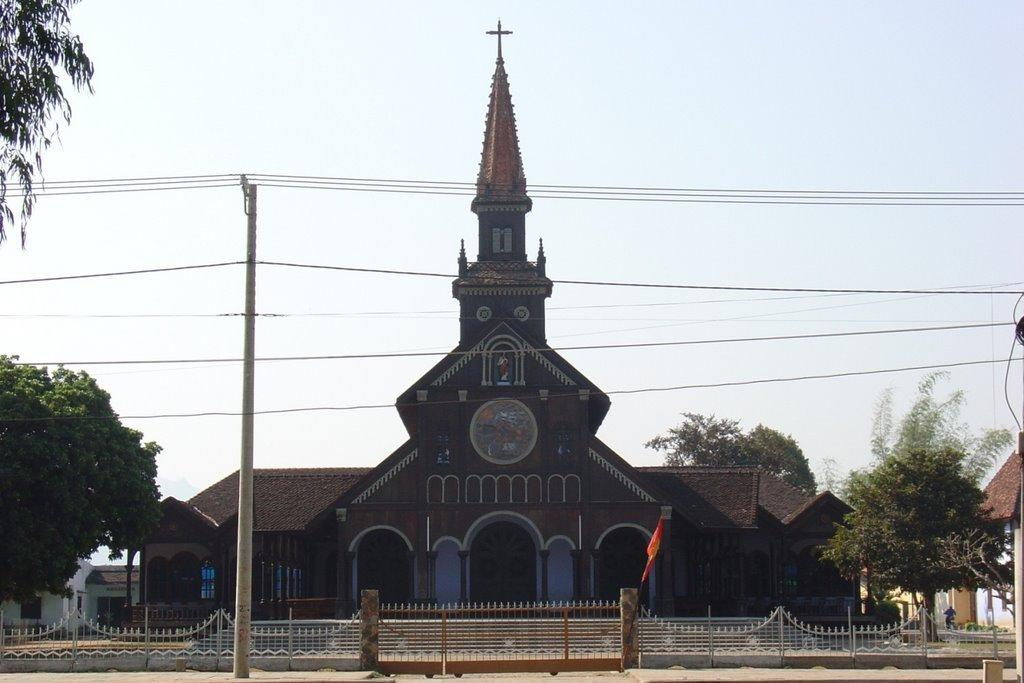What type of structures can be seen in the image? There are buildings in the image. What other natural elements are present in the image? There are trees in the image. What is the person in the image doing? There is a person on a bike in the image. What type of barrier can be seen in the image? There is a gate and fencing in the image. What other man-made objects can be seen in the image? There are poles and wires in the image. What part of the natural environment is visible in the image? The sky is visible in the image. What type of whistle can be heard in the image? There is no whistle present in the image, and therefore no sound can be heard. What type of road can be seen in the image? There is no road visible in the image. 